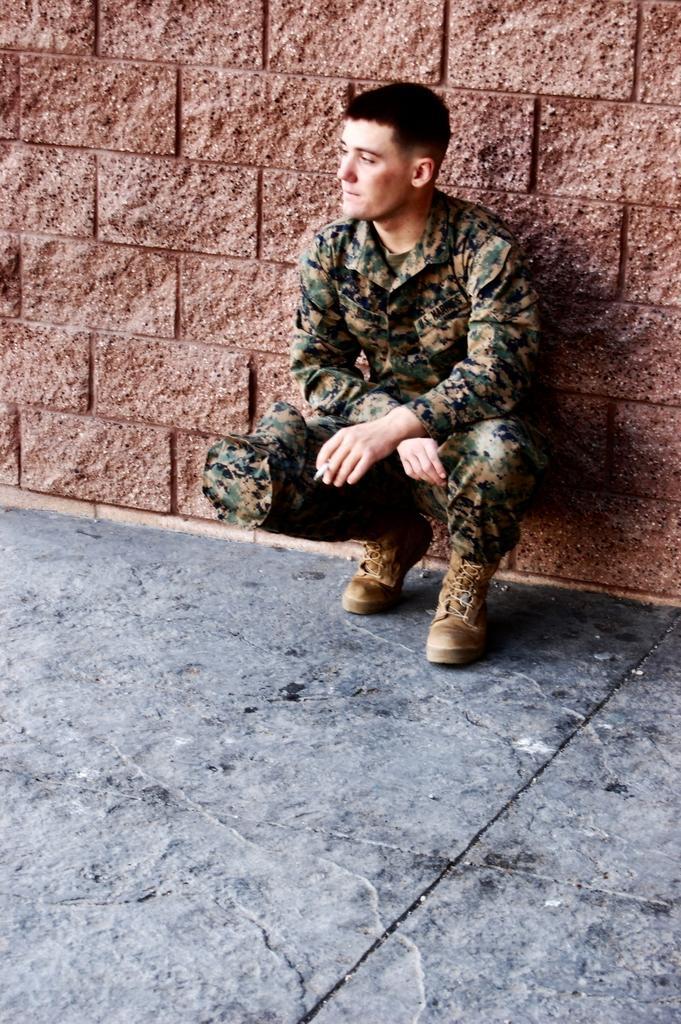Please provide a concise description of this image. In this image, we can see a person in front of the wall. This person is wearing clothes and shoes. 